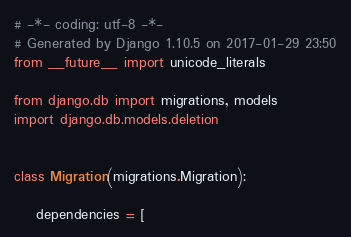<code> <loc_0><loc_0><loc_500><loc_500><_Python_># -*- coding: utf-8 -*-
# Generated by Django 1.10.5 on 2017-01-29 23:50
from __future__ import unicode_literals

from django.db import migrations, models
import django.db.models.deletion


class Migration(migrations.Migration):

    dependencies = [</code> 